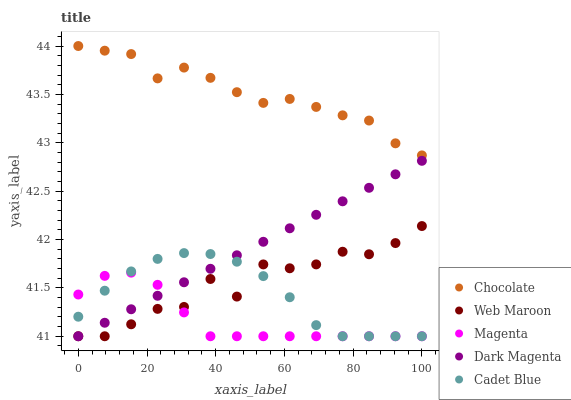Does Magenta have the minimum area under the curve?
Answer yes or no. Yes. Does Chocolate have the maximum area under the curve?
Answer yes or no. Yes. Does Cadet Blue have the minimum area under the curve?
Answer yes or no. No. Does Cadet Blue have the maximum area under the curve?
Answer yes or no. No. Is Dark Magenta the smoothest?
Answer yes or no. Yes. Is Web Maroon the roughest?
Answer yes or no. Yes. Is Cadet Blue the smoothest?
Answer yes or no. No. Is Cadet Blue the roughest?
Answer yes or no. No. Does Magenta have the lowest value?
Answer yes or no. Yes. Does Chocolate have the lowest value?
Answer yes or no. No. Does Chocolate have the highest value?
Answer yes or no. Yes. Does Cadet Blue have the highest value?
Answer yes or no. No. Is Magenta less than Chocolate?
Answer yes or no. Yes. Is Chocolate greater than Cadet Blue?
Answer yes or no. Yes. Does Cadet Blue intersect Magenta?
Answer yes or no. Yes. Is Cadet Blue less than Magenta?
Answer yes or no. No. Is Cadet Blue greater than Magenta?
Answer yes or no. No. Does Magenta intersect Chocolate?
Answer yes or no. No. 